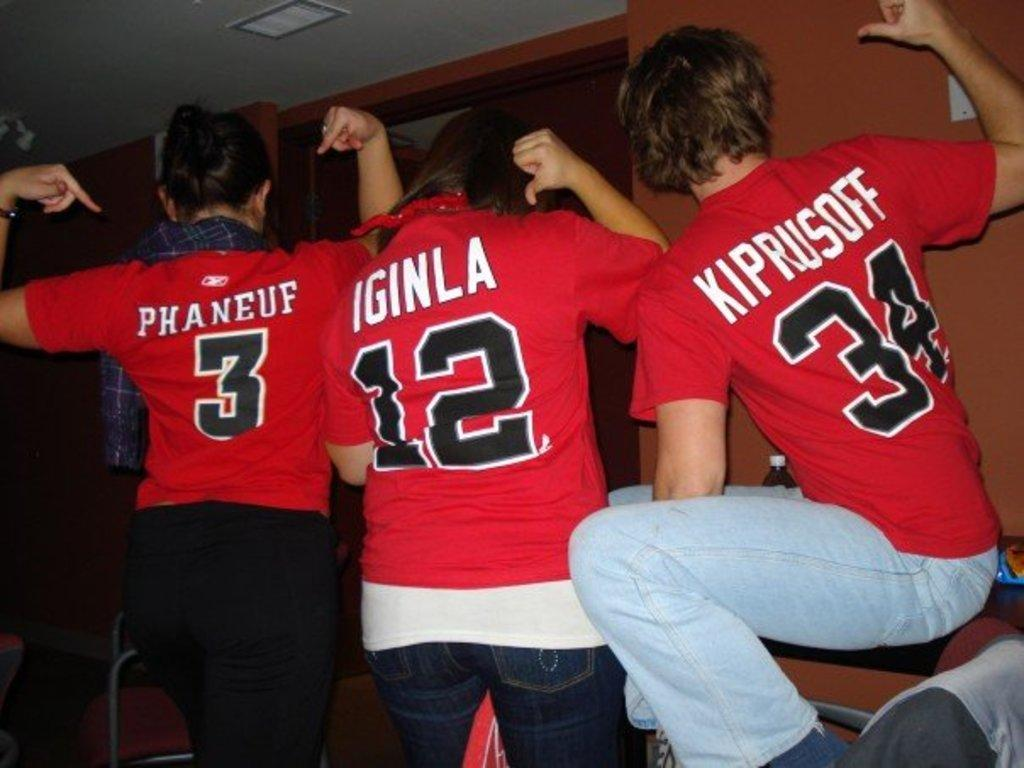<image>
Give a short and clear explanation of the subsequent image. Three people wearing jerseys with the digits 3 12 34. 